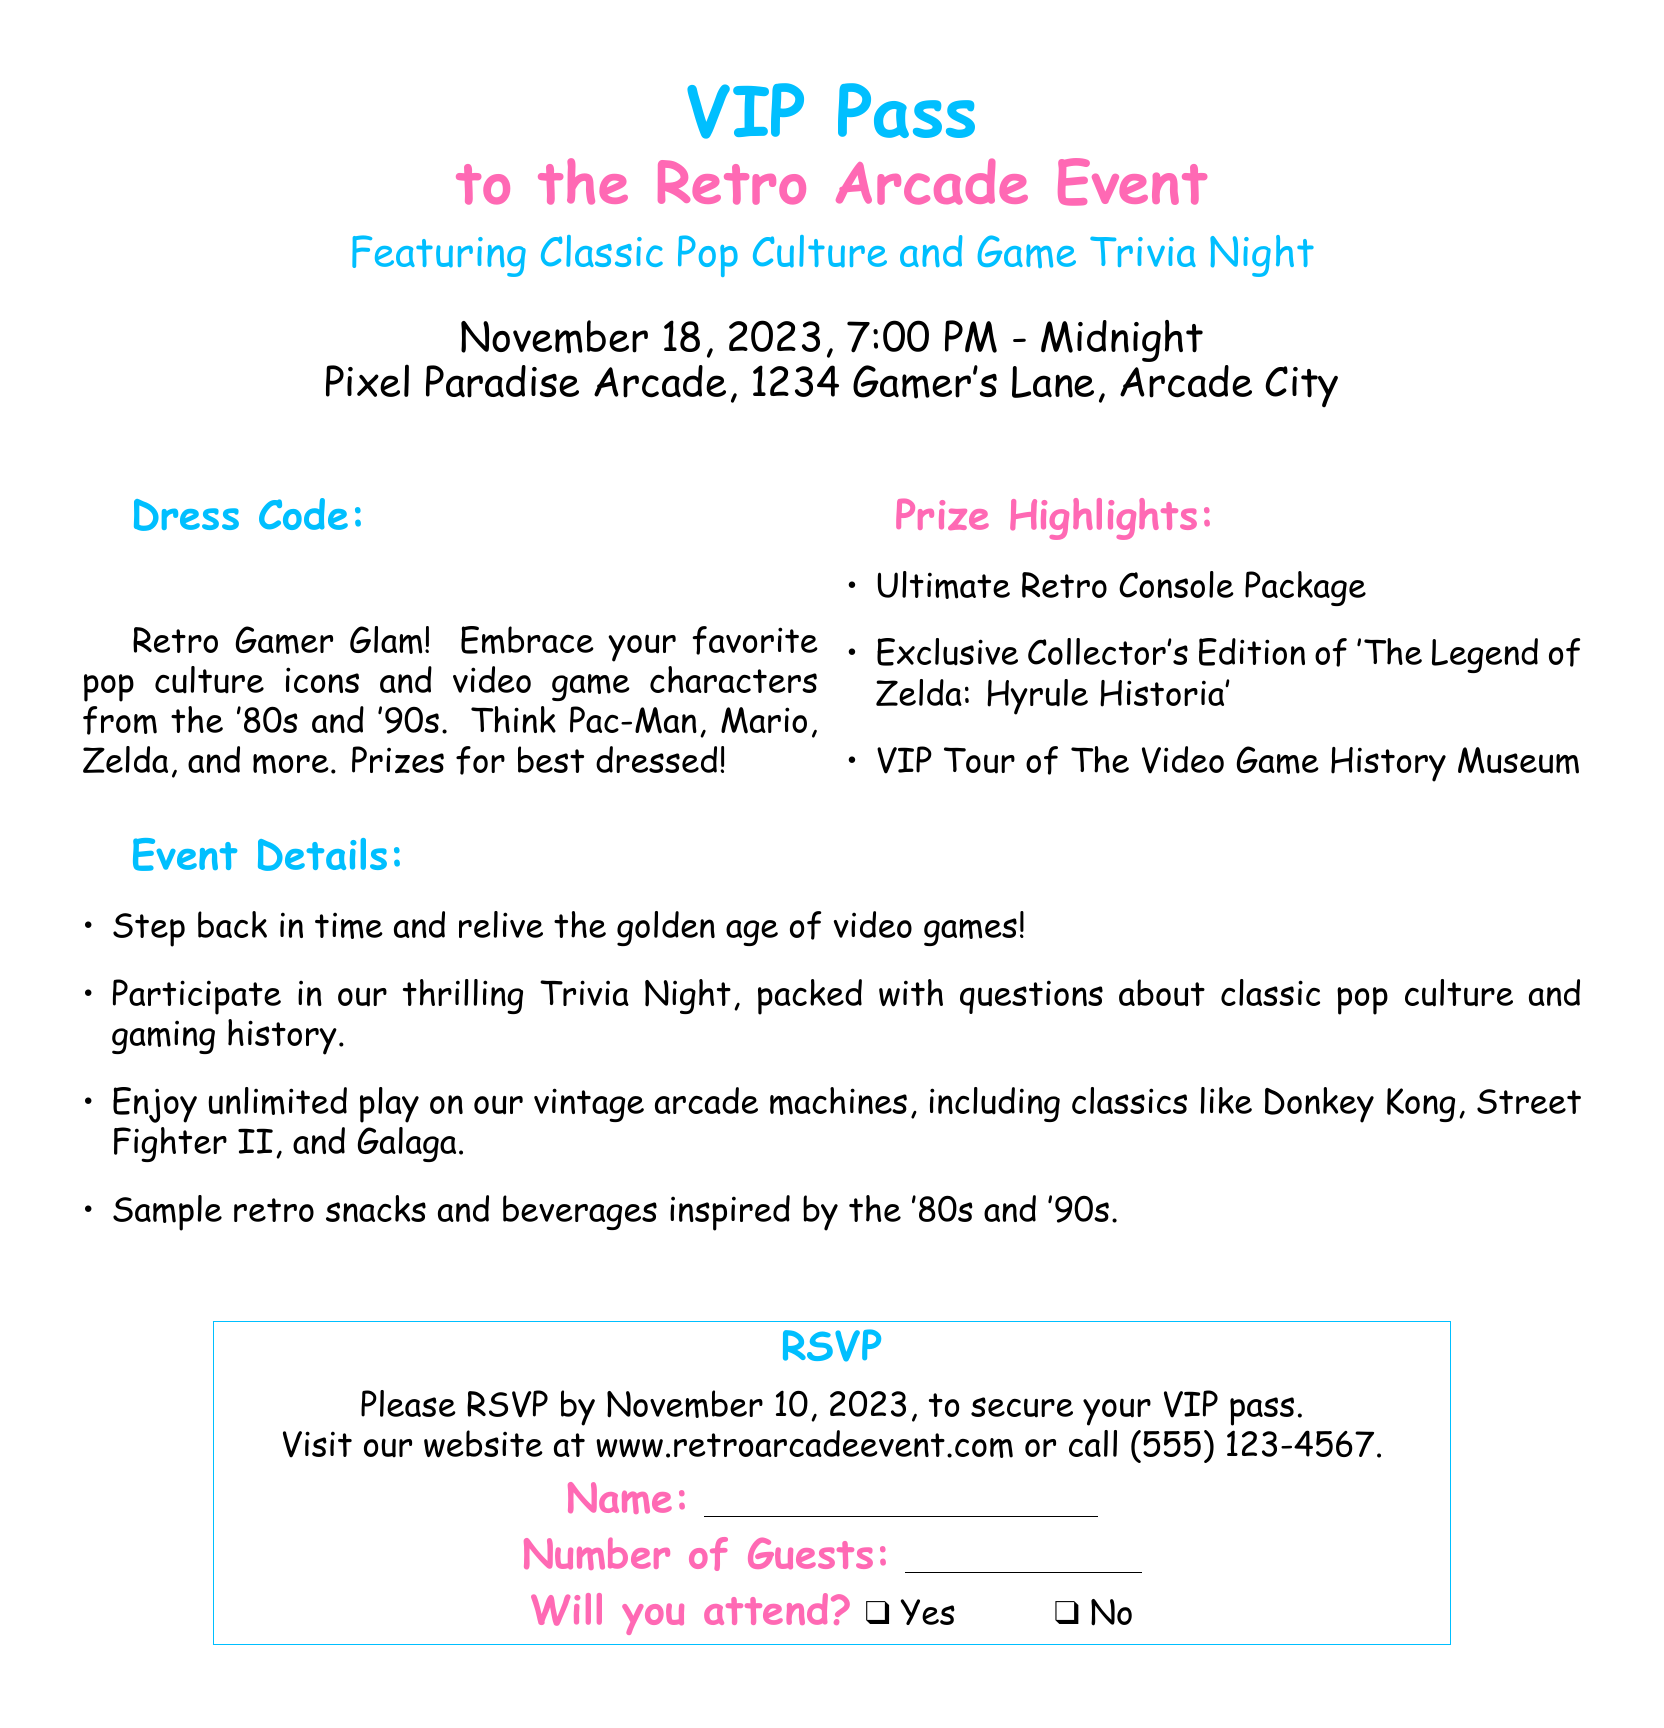What is the date of the event? The date of the event can be found in the document, which states it is scheduled for November 18, 2023.
Answer: November 18, 2023 What is the location of the event? The location is specified in the document as Pixel Paradise Arcade, 1234 Gamer's Lane, Arcade City.
Answer: Pixel Paradise Arcade, 1234 Gamer's Lane, Arcade City What time does the event start? The starting time of the event is indicated in the document as 7:00 PM.
Answer: 7:00 PM What type of dress code is required? The document states the dress code as "Retro Gamer Glam," which implies a specific theme for attire.
Answer: Retro Gamer Glam What is the prize for the best-dressed? The document mentions that there are prizes for the best dressed, but does not specify the exact prize.
Answer: Prizes for best dressed How many guests can be included in the RSVP? The RSVP section allows for specifying the number of guests but does not provide a limit.
Answer: Unlimited (not specified) By what date should attendees RSVP? The document clearly states that attendees need to RSVP by November 10, 2023.
Answer: November 10, 2023 What is one of the highlighted prizes at the event? Among the prize highlights listed in the document, one is the Ultimate Retro Console Package.
Answer: Ultimate Retro Console Package Will there be trivia at the event? The document mentions a Trivia Night, indicating that there will be trivia questions regarding pop culture and gaming.
Answer: Yes 